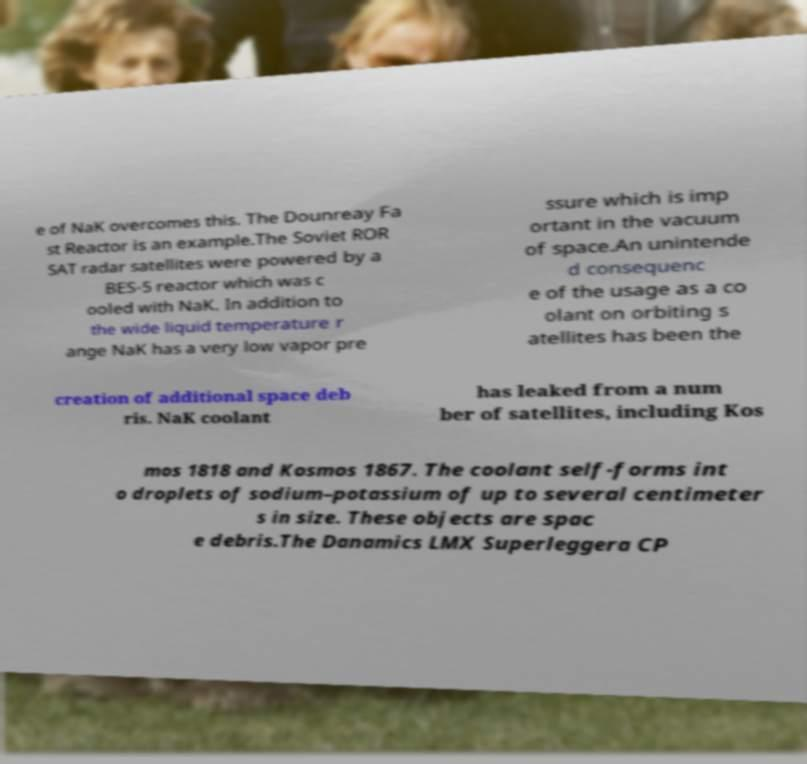Can you read and provide the text displayed in the image?This photo seems to have some interesting text. Can you extract and type it out for me? e of NaK overcomes this. The Dounreay Fa st Reactor is an example.The Soviet ROR SAT radar satellites were powered by a BES-5 reactor which was c ooled with NaK. In addition to the wide liquid temperature r ange NaK has a very low vapor pre ssure which is imp ortant in the vacuum of space.An unintende d consequenc e of the usage as a co olant on orbiting s atellites has been the creation of additional space deb ris. NaK coolant has leaked from a num ber of satellites, including Kos mos 1818 and Kosmos 1867. The coolant self-forms int o droplets of sodium–potassium of up to several centimeter s in size. These objects are spac e debris.The Danamics LMX Superleggera CP 